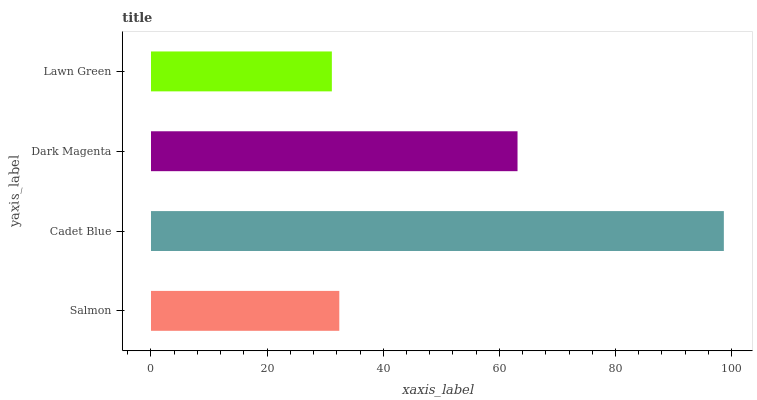Is Lawn Green the minimum?
Answer yes or no. Yes. Is Cadet Blue the maximum?
Answer yes or no. Yes. Is Dark Magenta the minimum?
Answer yes or no. No. Is Dark Magenta the maximum?
Answer yes or no. No. Is Cadet Blue greater than Dark Magenta?
Answer yes or no. Yes. Is Dark Magenta less than Cadet Blue?
Answer yes or no. Yes. Is Dark Magenta greater than Cadet Blue?
Answer yes or no. No. Is Cadet Blue less than Dark Magenta?
Answer yes or no. No. Is Dark Magenta the high median?
Answer yes or no. Yes. Is Salmon the low median?
Answer yes or no. Yes. Is Cadet Blue the high median?
Answer yes or no. No. Is Cadet Blue the low median?
Answer yes or no. No. 